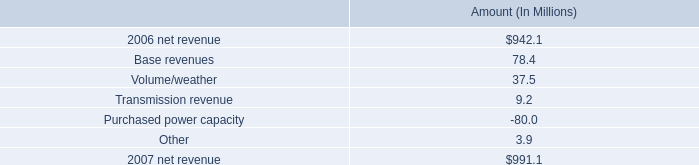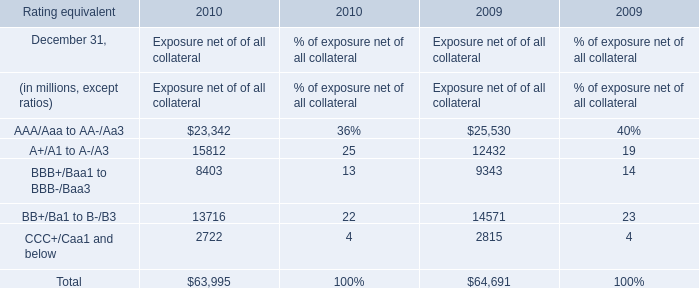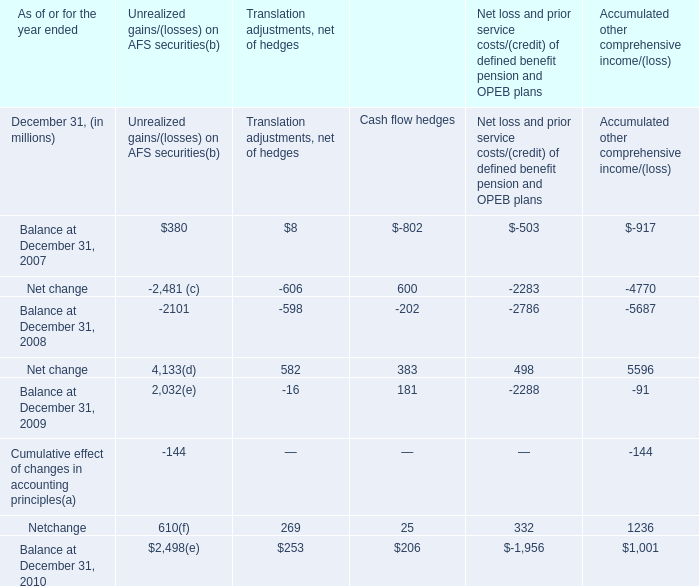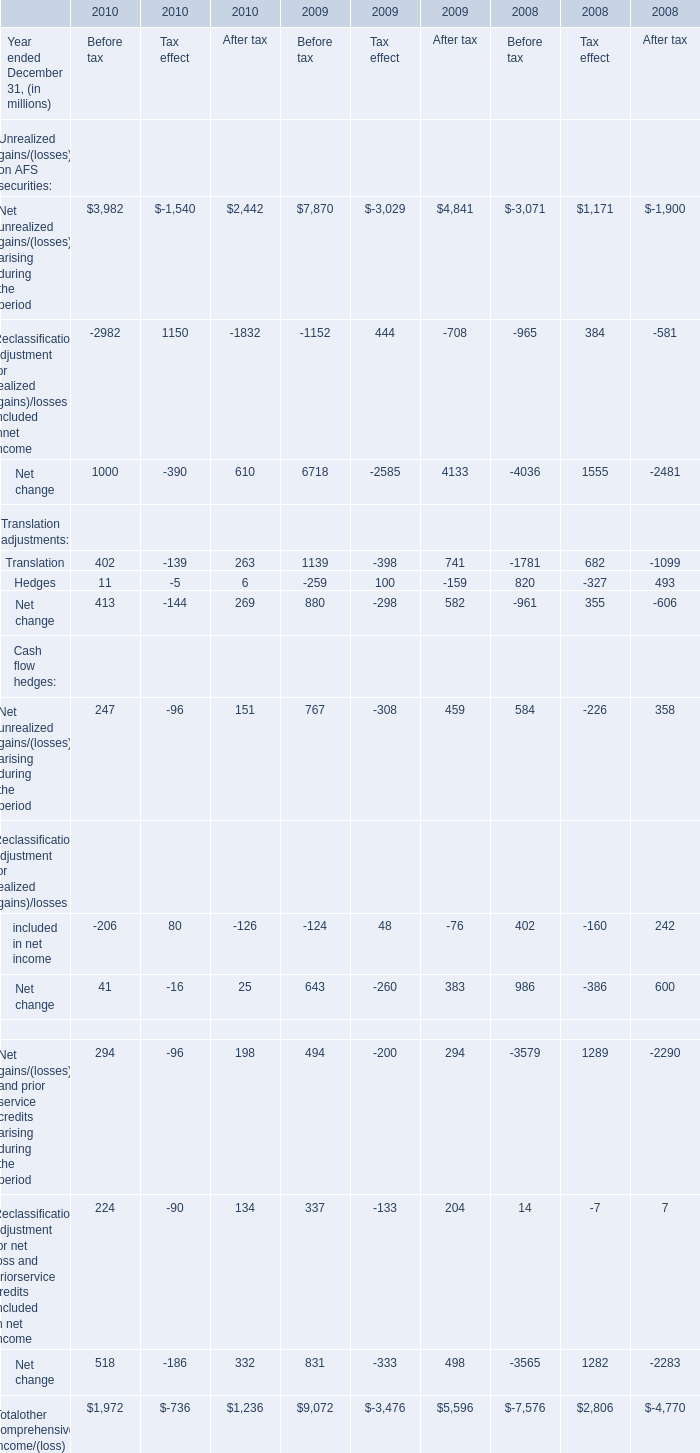If Translation for After tax develops with the same growth rate in 2010, what will it reach in 2011? (in million) 
Computations: ((1 + ((263 - 741) / 741)) * 263)
Answer: 93.34548. 